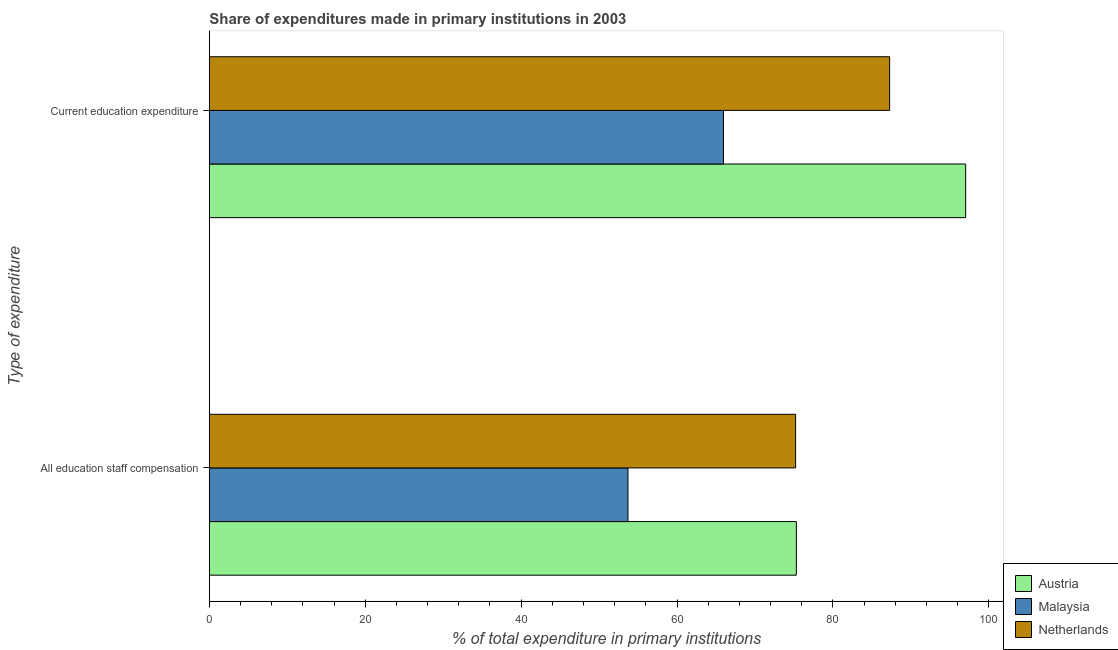How many different coloured bars are there?
Ensure brevity in your answer.  3. How many groups of bars are there?
Keep it short and to the point. 2. What is the label of the 2nd group of bars from the top?
Provide a succinct answer. All education staff compensation. What is the expenditure in staff compensation in Malaysia?
Keep it short and to the point. 53.71. Across all countries, what is the maximum expenditure in education?
Offer a terse response. 97.04. Across all countries, what is the minimum expenditure in education?
Offer a terse response. 65.96. In which country was the expenditure in staff compensation maximum?
Ensure brevity in your answer.  Austria. In which country was the expenditure in education minimum?
Provide a succinct answer. Malaysia. What is the total expenditure in education in the graph?
Keep it short and to the point. 250.29. What is the difference between the expenditure in education in Malaysia and that in Netherlands?
Keep it short and to the point. -21.32. What is the difference between the expenditure in education in Malaysia and the expenditure in staff compensation in Netherlands?
Keep it short and to the point. -9.26. What is the average expenditure in staff compensation per country?
Ensure brevity in your answer.  68.08. What is the difference between the expenditure in education and expenditure in staff compensation in Netherlands?
Provide a short and direct response. 12.06. In how many countries, is the expenditure in education greater than 88 %?
Provide a succinct answer. 1. What is the ratio of the expenditure in education in Netherlands to that in Malaysia?
Make the answer very short. 1.32. Is the expenditure in staff compensation in Austria less than that in Malaysia?
Offer a terse response. No. In how many countries, is the expenditure in education greater than the average expenditure in education taken over all countries?
Keep it short and to the point. 2. What does the 2nd bar from the top in All education staff compensation represents?
Offer a very short reply. Malaysia. How many countries are there in the graph?
Provide a short and direct response. 3. What is the difference between two consecutive major ticks on the X-axis?
Make the answer very short. 20. Does the graph contain any zero values?
Provide a succinct answer. No. Does the graph contain grids?
Your answer should be compact. No. How many legend labels are there?
Your answer should be compact. 3. What is the title of the graph?
Ensure brevity in your answer.  Share of expenditures made in primary institutions in 2003. What is the label or title of the X-axis?
Your answer should be compact. % of total expenditure in primary institutions. What is the label or title of the Y-axis?
Provide a short and direct response. Type of expenditure. What is the % of total expenditure in primary institutions in Austria in All education staff compensation?
Give a very brief answer. 75.31. What is the % of total expenditure in primary institutions of Malaysia in All education staff compensation?
Provide a short and direct response. 53.71. What is the % of total expenditure in primary institutions in Netherlands in All education staff compensation?
Provide a short and direct response. 75.22. What is the % of total expenditure in primary institutions in Austria in Current education expenditure?
Your response must be concise. 97.04. What is the % of total expenditure in primary institutions of Malaysia in Current education expenditure?
Provide a short and direct response. 65.96. What is the % of total expenditure in primary institutions of Netherlands in Current education expenditure?
Make the answer very short. 87.29. Across all Type of expenditure, what is the maximum % of total expenditure in primary institutions of Austria?
Your response must be concise. 97.04. Across all Type of expenditure, what is the maximum % of total expenditure in primary institutions of Malaysia?
Offer a terse response. 65.96. Across all Type of expenditure, what is the maximum % of total expenditure in primary institutions of Netherlands?
Make the answer very short. 87.29. Across all Type of expenditure, what is the minimum % of total expenditure in primary institutions of Austria?
Make the answer very short. 75.31. Across all Type of expenditure, what is the minimum % of total expenditure in primary institutions of Malaysia?
Keep it short and to the point. 53.71. Across all Type of expenditure, what is the minimum % of total expenditure in primary institutions of Netherlands?
Ensure brevity in your answer.  75.22. What is the total % of total expenditure in primary institutions in Austria in the graph?
Your answer should be compact. 172.36. What is the total % of total expenditure in primary institutions in Malaysia in the graph?
Offer a very short reply. 119.67. What is the total % of total expenditure in primary institutions in Netherlands in the graph?
Keep it short and to the point. 162.51. What is the difference between the % of total expenditure in primary institutions of Austria in All education staff compensation and that in Current education expenditure?
Offer a very short reply. -21.73. What is the difference between the % of total expenditure in primary institutions of Malaysia in All education staff compensation and that in Current education expenditure?
Offer a very short reply. -12.26. What is the difference between the % of total expenditure in primary institutions of Netherlands in All education staff compensation and that in Current education expenditure?
Provide a short and direct response. -12.06. What is the difference between the % of total expenditure in primary institutions of Austria in All education staff compensation and the % of total expenditure in primary institutions of Malaysia in Current education expenditure?
Your answer should be compact. 9.35. What is the difference between the % of total expenditure in primary institutions in Austria in All education staff compensation and the % of total expenditure in primary institutions in Netherlands in Current education expenditure?
Provide a short and direct response. -11.97. What is the difference between the % of total expenditure in primary institutions of Malaysia in All education staff compensation and the % of total expenditure in primary institutions of Netherlands in Current education expenditure?
Offer a terse response. -33.58. What is the average % of total expenditure in primary institutions in Austria per Type of expenditure?
Make the answer very short. 86.18. What is the average % of total expenditure in primary institutions of Malaysia per Type of expenditure?
Your response must be concise. 59.83. What is the average % of total expenditure in primary institutions of Netherlands per Type of expenditure?
Make the answer very short. 81.25. What is the difference between the % of total expenditure in primary institutions in Austria and % of total expenditure in primary institutions in Malaysia in All education staff compensation?
Provide a succinct answer. 21.61. What is the difference between the % of total expenditure in primary institutions in Austria and % of total expenditure in primary institutions in Netherlands in All education staff compensation?
Keep it short and to the point. 0.09. What is the difference between the % of total expenditure in primary institutions in Malaysia and % of total expenditure in primary institutions in Netherlands in All education staff compensation?
Give a very brief answer. -21.52. What is the difference between the % of total expenditure in primary institutions of Austria and % of total expenditure in primary institutions of Malaysia in Current education expenditure?
Ensure brevity in your answer.  31.08. What is the difference between the % of total expenditure in primary institutions in Austria and % of total expenditure in primary institutions in Netherlands in Current education expenditure?
Your answer should be very brief. 9.76. What is the difference between the % of total expenditure in primary institutions in Malaysia and % of total expenditure in primary institutions in Netherlands in Current education expenditure?
Ensure brevity in your answer.  -21.32. What is the ratio of the % of total expenditure in primary institutions of Austria in All education staff compensation to that in Current education expenditure?
Provide a short and direct response. 0.78. What is the ratio of the % of total expenditure in primary institutions in Malaysia in All education staff compensation to that in Current education expenditure?
Your answer should be very brief. 0.81. What is the ratio of the % of total expenditure in primary institutions of Netherlands in All education staff compensation to that in Current education expenditure?
Keep it short and to the point. 0.86. What is the difference between the highest and the second highest % of total expenditure in primary institutions in Austria?
Your answer should be very brief. 21.73. What is the difference between the highest and the second highest % of total expenditure in primary institutions in Malaysia?
Provide a short and direct response. 12.26. What is the difference between the highest and the second highest % of total expenditure in primary institutions in Netherlands?
Keep it short and to the point. 12.06. What is the difference between the highest and the lowest % of total expenditure in primary institutions of Austria?
Your response must be concise. 21.73. What is the difference between the highest and the lowest % of total expenditure in primary institutions in Malaysia?
Your response must be concise. 12.26. What is the difference between the highest and the lowest % of total expenditure in primary institutions of Netherlands?
Give a very brief answer. 12.06. 